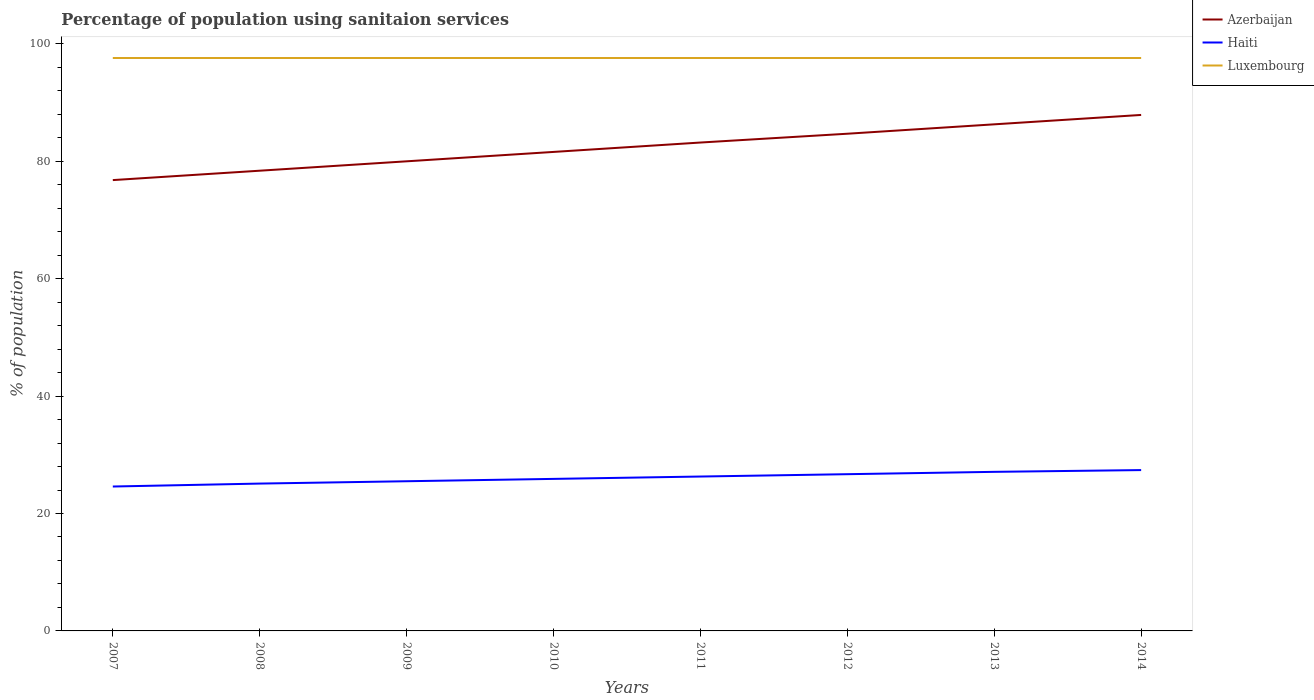Across all years, what is the maximum percentage of population using sanitaion services in Azerbaijan?
Offer a terse response. 76.8. What is the total percentage of population using sanitaion services in Azerbaijan in the graph?
Provide a succinct answer. -6.3. What is the difference between the highest and the second highest percentage of population using sanitaion services in Azerbaijan?
Make the answer very short. 11.1. How many lines are there?
Give a very brief answer. 3. How many years are there in the graph?
Keep it short and to the point. 8. What is the difference between two consecutive major ticks on the Y-axis?
Make the answer very short. 20. Are the values on the major ticks of Y-axis written in scientific E-notation?
Ensure brevity in your answer.  No. Does the graph contain any zero values?
Keep it short and to the point. No. What is the title of the graph?
Give a very brief answer. Percentage of population using sanitaion services. What is the label or title of the Y-axis?
Offer a terse response. % of population. What is the % of population in Azerbaijan in 2007?
Make the answer very short. 76.8. What is the % of population in Haiti in 2007?
Your answer should be compact. 24.6. What is the % of population in Luxembourg in 2007?
Give a very brief answer. 97.6. What is the % of population in Azerbaijan in 2008?
Give a very brief answer. 78.4. What is the % of population of Haiti in 2008?
Offer a very short reply. 25.1. What is the % of population of Luxembourg in 2008?
Provide a succinct answer. 97.6. What is the % of population in Azerbaijan in 2009?
Provide a succinct answer. 80. What is the % of population in Haiti in 2009?
Keep it short and to the point. 25.5. What is the % of population in Luxembourg in 2009?
Give a very brief answer. 97.6. What is the % of population of Azerbaijan in 2010?
Provide a succinct answer. 81.6. What is the % of population of Haiti in 2010?
Provide a succinct answer. 25.9. What is the % of population in Luxembourg in 2010?
Provide a succinct answer. 97.6. What is the % of population of Azerbaijan in 2011?
Your answer should be compact. 83.2. What is the % of population of Haiti in 2011?
Your response must be concise. 26.3. What is the % of population of Luxembourg in 2011?
Give a very brief answer. 97.6. What is the % of population of Azerbaijan in 2012?
Offer a very short reply. 84.7. What is the % of population in Haiti in 2012?
Offer a very short reply. 26.7. What is the % of population in Luxembourg in 2012?
Your answer should be compact. 97.6. What is the % of population in Azerbaijan in 2013?
Give a very brief answer. 86.3. What is the % of population in Haiti in 2013?
Make the answer very short. 27.1. What is the % of population of Luxembourg in 2013?
Provide a short and direct response. 97.6. What is the % of population of Azerbaijan in 2014?
Offer a terse response. 87.9. What is the % of population of Haiti in 2014?
Offer a terse response. 27.4. What is the % of population of Luxembourg in 2014?
Keep it short and to the point. 97.6. Across all years, what is the maximum % of population in Azerbaijan?
Offer a very short reply. 87.9. Across all years, what is the maximum % of population of Haiti?
Ensure brevity in your answer.  27.4. Across all years, what is the maximum % of population in Luxembourg?
Make the answer very short. 97.6. Across all years, what is the minimum % of population in Azerbaijan?
Offer a terse response. 76.8. Across all years, what is the minimum % of population of Haiti?
Offer a terse response. 24.6. Across all years, what is the minimum % of population of Luxembourg?
Keep it short and to the point. 97.6. What is the total % of population in Azerbaijan in the graph?
Offer a terse response. 658.9. What is the total % of population in Haiti in the graph?
Offer a terse response. 208.6. What is the total % of population of Luxembourg in the graph?
Offer a very short reply. 780.8. What is the difference between the % of population in Azerbaijan in 2007 and that in 2008?
Ensure brevity in your answer.  -1.6. What is the difference between the % of population in Luxembourg in 2007 and that in 2008?
Offer a terse response. 0. What is the difference between the % of population in Luxembourg in 2007 and that in 2009?
Ensure brevity in your answer.  0. What is the difference between the % of population of Azerbaijan in 2007 and that in 2010?
Keep it short and to the point. -4.8. What is the difference between the % of population of Luxembourg in 2007 and that in 2010?
Offer a terse response. 0. What is the difference between the % of population in Azerbaijan in 2007 and that in 2011?
Keep it short and to the point. -6.4. What is the difference between the % of population in Azerbaijan in 2007 and that in 2012?
Give a very brief answer. -7.9. What is the difference between the % of population of Azerbaijan in 2007 and that in 2013?
Offer a terse response. -9.5. What is the difference between the % of population in Azerbaijan in 2008 and that in 2009?
Provide a succinct answer. -1.6. What is the difference between the % of population of Haiti in 2008 and that in 2009?
Give a very brief answer. -0.4. What is the difference between the % of population of Luxembourg in 2008 and that in 2009?
Your response must be concise. 0. What is the difference between the % of population in Azerbaijan in 2008 and that in 2010?
Your response must be concise. -3.2. What is the difference between the % of population of Haiti in 2008 and that in 2010?
Your answer should be compact. -0.8. What is the difference between the % of population of Luxembourg in 2008 and that in 2010?
Offer a terse response. 0. What is the difference between the % of population of Azerbaijan in 2008 and that in 2014?
Provide a succinct answer. -9.5. What is the difference between the % of population in Luxembourg in 2008 and that in 2014?
Provide a short and direct response. 0. What is the difference between the % of population of Azerbaijan in 2009 and that in 2010?
Give a very brief answer. -1.6. What is the difference between the % of population in Haiti in 2009 and that in 2010?
Give a very brief answer. -0.4. What is the difference between the % of population in Haiti in 2009 and that in 2011?
Provide a succinct answer. -0.8. What is the difference between the % of population of Azerbaijan in 2009 and that in 2013?
Your response must be concise. -6.3. What is the difference between the % of population in Haiti in 2009 and that in 2013?
Make the answer very short. -1.6. What is the difference between the % of population in Luxembourg in 2009 and that in 2013?
Provide a short and direct response. 0. What is the difference between the % of population in Azerbaijan in 2009 and that in 2014?
Make the answer very short. -7.9. What is the difference between the % of population of Haiti in 2009 and that in 2014?
Provide a succinct answer. -1.9. What is the difference between the % of population in Luxembourg in 2009 and that in 2014?
Offer a terse response. 0. What is the difference between the % of population in Azerbaijan in 2010 and that in 2011?
Provide a succinct answer. -1.6. What is the difference between the % of population in Haiti in 2010 and that in 2011?
Offer a very short reply. -0.4. What is the difference between the % of population in Haiti in 2010 and that in 2013?
Your response must be concise. -1.2. What is the difference between the % of population in Luxembourg in 2010 and that in 2013?
Ensure brevity in your answer.  0. What is the difference between the % of population of Haiti in 2010 and that in 2014?
Make the answer very short. -1.5. What is the difference between the % of population of Azerbaijan in 2011 and that in 2012?
Give a very brief answer. -1.5. What is the difference between the % of population in Haiti in 2011 and that in 2012?
Ensure brevity in your answer.  -0.4. What is the difference between the % of population of Luxembourg in 2011 and that in 2012?
Ensure brevity in your answer.  0. What is the difference between the % of population in Azerbaijan in 2011 and that in 2013?
Provide a succinct answer. -3.1. What is the difference between the % of population in Luxembourg in 2011 and that in 2013?
Make the answer very short. 0. What is the difference between the % of population in Luxembourg in 2012 and that in 2014?
Your response must be concise. 0. What is the difference between the % of population of Azerbaijan in 2007 and the % of population of Haiti in 2008?
Offer a terse response. 51.7. What is the difference between the % of population in Azerbaijan in 2007 and the % of population in Luxembourg in 2008?
Your answer should be compact. -20.8. What is the difference between the % of population of Haiti in 2007 and the % of population of Luxembourg in 2008?
Offer a very short reply. -73. What is the difference between the % of population of Azerbaijan in 2007 and the % of population of Haiti in 2009?
Keep it short and to the point. 51.3. What is the difference between the % of population in Azerbaijan in 2007 and the % of population in Luxembourg in 2009?
Your answer should be compact. -20.8. What is the difference between the % of population of Haiti in 2007 and the % of population of Luxembourg in 2009?
Your answer should be very brief. -73. What is the difference between the % of population of Azerbaijan in 2007 and the % of population of Haiti in 2010?
Make the answer very short. 50.9. What is the difference between the % of population of Azerbaijan in 2007 and the % of population of Luxembourg in 2010?
Offer a terse response. -20.8. What is the difference between the % of population in Haiti in 2007 and the % of population in Luxembourg in 2010?
Your response must be concise. -73. What is the difference between the % of population in Azerbaijan in 2007 and the % of population in Haiti in 2011?
Keep it short and to the point. 50.5. What is the difference between the % of population of Azerbaijan in 2007 and the % of population of Luxembourg in 2011?
Make the answer very short. -20.8. What is the difference between the % of population of Haiti in 2007 and the % of population of Luxembourg in 2011?
Your answer should be very brief. -73. What is the difference between the % of population of Azerbaijan in 2007 and the % of population of Haiti in 2012?
Make the answer very short. 50.1. What is the difference between the % of population in Azerbaijan in 2007 and the % of population in Luxembourg in 2012?
Give a very brief answer. -20.8. What is the difference between the % of population of Haiti in 2007 and the % of population of Luxembourg in 2012?
Provide a succinct answer. -73. What is the difference between the % of population in Azerbaijan in 2007 and the % of population in Haiti in 2013?
Give a very brief answer. 49.7. What is the difference between the % of population of Azerbaijan in 2007 and the % of population of Luxembourg in 2013?
Provide a short and direct response. -20.8. What is the difference between the % of population in Haiti in 2007 and the % of population in Luxembourg in 2013?
Your answer should be very brief. -73. What is the difference between the % of population in Azerbaijan in 2007 and the % of population in Haiti in 2014?
Offer a very short reply. 49.4. What is the difference between the % of population of Azerbaijan in 2007 and the % of population of Luxembourg in 2014?
Offer a very short reply. -20.8. What is the difference between the % of population of Haiti in 2007 and the % of population of Luxembourg in 2014?
Your response must be concise. -73. What is the difference between the % of population in Azerbaijan in 2008 and the % of population in Haiti in 2009?
Your answer should be compact. 52.9. What is the difference between the % of population in Azerbaijan in 2008 and the % of population in Luxembourg in 2009?
Your answer should be compact. -19.2. What is the difference between the % of population in Haiti in 2008 and the % of population in Luxembourg in 2009?
Make the answer very short. -72.5. What is the difference between the % of population of Azerbaijan in 2008 and the % of population of Haiti in 2010?
Provide a short and direct response. 52.5. What is the difference between the % of population in Azerbaijan in 2008 and the % of population in Luxembourg in 2010?
Keep it short and to the point. -19.2. What is the difference between the % of population of Haiti in 2008 and the % of population of Luxembourg in 2010?
Your answer should be very brief. -72.5. What is the difference between the % of population in Azerbaijan in 2008 and the % of population in Haiti in 2011?
Provide a short and direct response. 52.1. What is the difference between the % of population in Azerbaijan in 2008 and the % of population in Luxembourg in 2011?
Offer a very short reply. -19.2. What is the difference between the % of population of Haiti in 2008 and the % of population of Luxembourg in 2011?
Make the answer very short. -72.5. What is the difference between the % of population of Azerbaijan in 2008 and the % of population of Haiti in 2012?
Give a very brief answer. 51.7. What is the difference between the % of population of Azerbaijan in 2008 and the % of population of Luxembourg in 2012?
Offer a very short reply. -19.2. What is the difference between the % of population of Haiti in 2008 and the % of population of Luxembourg in 2012?
Your response must be concise. -72.5. What is the difference between the % of population in Azerbaijan in 2008 and the % of population in Haiti in 2013?
Provide a succinct answer. 51.3. What is the difference between the % of population of Azerbaijan in 2008 and the % of population of Luxembourg in 2013?
Provide a short and direct response. -19.2. What is the difference between the % of population in Haiti in 2008 and the % of population in Luxembourg in 2013?
Offer a very short reply. -72.5. What is the difference between the % of population in Azerbaijan in 2008 and the % of population in Haiti in 2014?
Ensure brevity in your answer.  51. What is the difference between the % of population of Azerbaijan in 2008 and the % of population of Luxembourg in 2014?
Keep it short and to the point. -19.2. What is the difference between the % of population in Haiti in 2008 and the % of population in Luxembourg in 2014?
Provide a succinct answer. -72.5. What is the difference between the % of population in Azerbaijan in 2009 and the % of population in Haiti in 2010?
Make the answer very short. 54.1. What is the difference between the % of population of Azerbaijan in 2009 and the % of population of Luxembourg in 2010?
Your answer should be very brief. -17.6. What is the difference between the % of population in Haiti in 2009 and the % of population in Luxembourg in 2010?
Provide a short and direct response. -72.1. What is the difference between the % of population in Azerbaijan in 2009 and the % of population in Haiti in 2011?
Offer a very short reply. 53.7. What is the difference between the % of population of Azerbaijan in 2009 and the % of population of Luxembourg in 2011?
Your answer should be very brief. -17.6. What is the difference between the % of population in Haiti in 2009 and the % of population in Luxembourg in 2011?
Give a very brief answer. -72.1. What is the difference between the % of population of Azerbaijan in 2009 and the % of population of Haiti in 2012?
Offer a terse response. 53.3. What is the difference between the % of population in Azerbaijan in 2009 and the % of population in Luxembourg in 2012?
Your response must be concise. -17.6. What is the difference between the % of population of Haiti in 2009 and the % of population of Luxembourg in 2012?
Give a very brief answer. -72.1. What is the difference between the % of population of Azerbaijan in 2009 and the % of population of Haiti in 2013?
Give a very brief answer. 52.9. What is the difference between the % of population in Azerbaijan in 2009 and the % of population in Luxembourg in 2013?
Your answer should be compact. -17.6. What is the difference between the % of population in Haiti in 2009 and the % of population in Luxembourg in 2013?
Provide a succinct answer. -72.1. What is the difference between the % of population in Azerbaijan in 2009 and the % of population in Haiti in 2014?
Ensure brevity in your answer.  52.6. What is the difference between the % of population of Azerbaijan in 2009 and the % of population of Luxembourg in 2014?
Offer a very short reply. -17.6. What is the difference between the % of population of Haiti in 2009 and the % of population of Luxembourg in 2014?
Offer a terse response. -72.1. What is the difference between the % of population of Azerbaijan in 2010 and the % of population of Haiti in 2011?
Provide a short and direct response. 55.3. What is the difference between the % of population in Haiti in 2010 and the % of population in Luxembourg in 2011?
Ensure brevity in your answer.  -71.7. What is the difference between the % of population of Azerbaijan in 2010 and the % of population of Haiti in 2012?
Give a very brief answer. 54.9. What is the difference between the % of population in Haiti in 2010 and the % of population in Luxembourg in 2012?
Provide a short and direct response. -71.7. What is the difference between the % of population of Azerbaijan in 2010 and the % of population of Haiti in 2013?
Your answer should be compact. 54.5. What is the difference between the % of population in Haiti in 2010 and the % of population in Luxembourg in 2013?
Provide a succinct answer. -71.7. What is the difference between the % of population of Azerbaijan in 2010 and the % of population of Haiti in 2014?
Keep it short and to the point. 54.2. What is the difference between the % of population in Azerbaijan in 2010 and the % of population in Luxembourg in 2014?
Ensure brevity in your answer.  -16. What is the difference between the % of population of Haiti in 2010 and the % of population of Luxembourg in 2014?
Give a very brief answer. -71.7. What is the difference between the % of population of Azerbaijan in 2011 and the % of population of Haiti in 2012?
Provide a short and direct response. 56.5. What is the difference between the % of population of Azerbaijan in 2011 and the % of population of Luxembourg in 2012?
Your response must be concise. -14.4. What is the difference between the % of population in Haiti in 2011 and the % of population in Luxembourg in 2012?
Your answer should be compact. -71.3. What is the difference between the % of population in Azerbaijan in 2011 and the % of population in Haiti in 2013?
Offer a terse response. 56.1. What is the difference between the % of population in Azerbaijan in 2011 and the % of population in Luxembourg in 2013?
Offer a very short reply. -14.4. What is the difference between the % of population in Haiti in 2011 and the % of population in Luxembourg in 2013?
Your answer should be compact. -71.3. What is the difference between the % of population of Azerbaijan in 2011 and the % of population of Haiti in 2014?
Keep it short and to the point. 55.8. What is the difference between the % of population of Azerbaijan in 2011 and the % of population of Luxembourg in 2014?
Keep it short and to the point. -14.4. What is the difference between the % of population in Haiti in 2011 and the % of population in Luxembourg in 2014?
Give a very brief answer. -71.3. What is the difference between the % of population of Azerbaijan in 2012 and the % of population of Haiti in 2013?
Your answer should be very brief. 57.6. What is the difference between the % of population in Haiti in 2012 and the % of population in Luxembourg in 2013?
Ensure brevity in your answer.  -70.9. What is the difference between the % of population in Azerbaijan in 2012 and the % of population in Haiti in 2014?
Provide a short and direct response. 57.3. What is the difference between the % of population of Haiti in 2012 and the % of population of Luxembourg in 2014?
Offer a terse response. -70.9. What is the difference between the % of population of Azerbaijan in 2013 and the % of population of Haiti in 2014?
Give a very brief answer. 58.9. What is the difference between the % of population of Azerbaijan in 2013 and the % of population of Luxembourg in 2014?
Your answer should be very brief. -11.3. What is the difference between the % of population in Haiti in 2013 and the % of population in Luxembourg in 2014?
Your answer should be compact. -70.5. What is the average % of population of Azerbaijan per year?
Your answer should be compact. 82.36. What is the average % of population of Haiti per year?
Give a very brief answer. 26.07. What is the average % of population of Luxembourg per year?
Ensure brevity in your answer.  97.6. In the year 2007, what is the difference between the % of population of Azerbaijan and % of population of Haiti?
Provide a succinct answer. 52.2. In the year 2007, what is the difference between the % of population of Azerbaijan and % of population of Luxembourg?
Your response must be concise. -20.8. In the year 2007, what is the difference between the % of population in Haiti and % of population in Luxembourg?
Your response must be concise. -73. In the year 2008, what is the difference between the % of population of Azerbaijan and % of population of Haiti?
Your response must be concise. 53.3. In the year 2008, what is the difference between the % of population in Azerbaijan and % of population in Luxembourg?
Ensure brevity in your answer.  -19.2. In the year 2008, what is the difference between the % of population in Haiti and % of population in Luxembourg?
Provide a short and direct response. -72.5. In the year 2009, what is the difference between the % of population of Azerbaijan and % of population of Haiti?
Provide a succinct answer. 54.5. In the year 2009, what is the difference between the % of population of Azerbaijan and % of population of Luxembourg?
Your answer should be compact. -17.6. In the year 2009, what is the difference between the % of population in Haiti and % of population in Luxembourg?
Provide a succinct answer. -72.1. In the year 2010, what is the difference between the % of population of Azerbaijan and % of population of Haiti?
Offer a very short reply. 55.7. In the year 2010, what is the difference between the % of population in Azerbaijan and % of population in Luxembourg?
Keep it short and to the point. -16. In the year 2010, what is the difference between the % of population of Haiti and % of population of Luxembourg?
Offer a terse response. -71.7. In the year 2011, what is the difference between the % of population in Azerbaijan and % of population in Haiti?
Provide a short and direct response. 56.9. In the year 2011, what is the difference between the % of population of Azerbaijan and % of population of Luxembourg?
Keep it short and to the point. -14.4. In the year 2011, what is the difference between the % of population of Haiti and % of population of Luxembourg?
Your answer should be compact. -71.3. In the year 2012, what is the difference between the % of population of Azerbaijan and % of population of Luxembourg?
Ensure brevity in your answer.  -12.9. In the year 2012, what is the difference between the % of population of Haiti and % of population of Luxembourg?
Provide a succinct answer. -70.9. In the year 2013, what is the difference between the % of population in Azerbaijan and % of population in Haiti?
Provide a short and direct response. 59.2. In the year 2013, what is the difference between the % of population of Haiti and % of population of Luxembourg?
Keep it short and to the point. -70.5. In the year 2014, what is the difference between the % of population in Azerbaijan and % of population in Haiti?
Keep it short and to the point. 60.5. In the year 2014, what is the difference between the % of population of Azerbaijan and % of population of Luxembourg?
Your answer should be compact. -9.7. In the year 2014, what is the difference between the % of population in Haiti and % of population in Luxembourg?
Provide a short and direct response. -70.2. What is the ratio of the % of population in Azerbaijan in 2007 to that in 2008?
Give a very brief answer. 0.98. What is the ratio of the % of population in Haiti in 2007 to that in 2008?
Offer a terse response. 0.98. What is the ratio of the % of population in Haiti in 2007 to that in 2009?
Your answer should be compact. 0.96. What is the ratio of the % of population of Luxembourg in 2007 to that in 2009?
Provide a short and direct response. 1. What is the ratio of the % of population in Haiti in 2007 to that in 2010?
Your response must be concise. 0.95. What is the ratio of the % of population in Luxembourg in 2007 to that in 2010?
Your response must be concise. 1. What is the ratio of the % of population in Azerbaijan in 2007 to that in 2011?
Keep it short and to the point. 0.92. What is the ratio of the % of population of Haiti in 2007 to that in 2011?
Your response must be concise. 0.94. What is the ratio of the % of population of Azerbaijan in 2007 to that in 2012?
Offer a very short reply. 0.91. What is the ratio of the % of population in Haiti in 2007 to that in 2012?
Give a very brief answer. 0.92. What is the ratio of the % of population in Luxembourg in 2007 to that in 2012?
Your response must be concise. 1. What is the ratio of the % of population in Azerbaijan in 2007 to that in 2013?
Ensure brevity in your answer.  0.89. What is the ratio of the % of population of Haiti in 2007 to that in 2013?
Offer a very short reply. 0.91. What is the ratio of the % of population of Azerbaijan in 2007 to that in 2014?
Your answer should be compact. 0.87. What is the ratio of the % of population of Haiti in 2007 to that in 2014?
Give a very brief answer. 0.9. What is the ratio of the % of population in Luxembourg in 2007 to that in 2014?
Your response must be concise. 1. What is the ratio of the % of population in Azerbaijan in 2008 to that in 2009?
Your response must be concise. 0.98. What is the ratio of the % of population in Haiti in 2008 to that in 2009?
Your answer should be compact. 0.98. What is the ratio of the % of population in Luxembourg in 2008 to that in 2009?
Keep it short and to the point. 1. What is the ratio of the % of population of Azerbaijan in 2008 to that in 2010?
Offer a very short reply. 0.96. What is the ratio of the % of population in Haiti in 2008 to that in 2010?
Ensure brevity in your answer.  0.97. What is the ratio of the % of population of Luxembourg in 2008 to that in 2010?
Give a very brief answer. 1. What is the ratio of the % of population in Azerbaijan in 2008 to that in 2011?
Offer a very short reply. 0.94. What is the ratio of the % of population in Haiti in 2008 to that in 2011?
Your response must be concise. 0.95. What is the ratio of the % of population in Luxembourg in 2008 to that in 2011?
Your answer should be very brief. 1. What is the ratio of the % of population of Azerbaijan in 2008 to that in 2012?
Give a very brief answer. 0.93. What is the ratio of the % of population of Haiti in 2008 to that in 2012?
Your answer should be compact. 0.94. What is the ratio of the % of population in Azerbaijan in 2008 to that in 2013?
Give a very brief answer. 0.91. What is the ratio of the % of population of Haiti in 2008 to that in 2013?
Give a very brief answer. 0.93. What is the ratio of the % of population in Luxembourg in 2008 to that in 2013?
Your response must be concise. 1. What is the ratio of the % of population of Azerbaijan in 2008 to that in 2014?
Offer a very short reply. 0.89. What is the ratio of the % of population in Haiti in 2008 to that in 2014?
Give a very brief answer. 0.92. What is the ratio of the % of population in Luxembourg in 2008 to that in 2014?
Ensure brevity in your answer.  1. What is the ratio of the % of population in Azerbaijan in 2009 to that in 2010?
Your response must be concise. 0.98. What is the ratio of the % of population of Haiti in 2009 to that in 2010?
Make the answer very short. 0.98. What is the ratio of the % of population in Luxembourg in 2009 to that in 2010?
Give a very brief answer. 1. What is the ratio of the % of population in Azerbaijan in 2009 to that in 2011?
Offer a terse response. 0.96. What is the ratio of the % of population of Haiti in 2009 to that in 2011?
Offer a terse response. 0.97. What is the ratio of the % of population in Luxembourg in 2009 to that in 2011?
Provide a short and direct response. 1. What is the ratio of the % of population of Azerbaijan in 2009 to that in 2012?
Your answer should be compact. 0.94. What is the ratio of the % of population of Haiti in 2009 to that in 2012?
Your answer should be very brief. 0.96. What is the ratio of the % of population in Luxembourg in 2009 to that in 2012?
Make the answer very short. 1. What is the ratio of the % of population of Azerbaijan in 2009 to that in 2013?
Ensure brevity in your answer.  0.93. What is the ratio of the % of population in Haiti in 2009 to that in 2013?
Provide a short and direct response. 0.94. What is the ratio of the % of population in Luxembourg in 2009 to that in 2013?
Offer a very short reply. 1. What is the ratio of the % of population of Azerbaijan in 2009 to that in 2014?
Provide a short and direct response. 0.91. What is the ratio of the % of population of Haiti in 2009 to that in 2014?
Keep it short and to the point. 0.93. What is the ratio of the % of population in Azerbaijan in 2010 to that in 2011?
Offer a very short reply. 0.98. What is the ratio of the % of population of Haiti in 2010 to that in 2011?
Provide a short and direct response. 0.98. What is the ratio of the % of population in Luxembourg in 2010 to that in 2011?
Provide a succinct answer. 1. What is the ratio of the % of population in Azerbaijan in 2010 to that in 2012?
Make the answer very short. 0.96. What is the ratio of the % of population in Azerbaijan in 2010 to that in 2013?
Offer a very short reply. 0.95. What is the ratio of the % of population of Haiti in 2010 to that in 2013?
Your answer should be very brief. 0.96. What is the ratio of the % of population in Luxembourg in 2010 to that in 2013?
Offer a terse response. 1. What is the ratio of the % of population in Azerbaijan in 2010 to that in 2014?
Provide a short and direct response. 0.93. What is the ratio of the % of population in Haiti in 2010 to that in 2014?
Your response must be concise. 0.95. What is the ratio of the % of population in Azerbaijan in 2011 to that in 2012?
Your answer should be very brief. 0.98. What is the ratio of the % of population of Haiti in 2011 to that in 2012?
Your answer should be very brief. 0.98. What is the ratio of the % of population of Luxembourg in 2011 to that in 2012?
Keep it short and to the point. 1. What is the ratio of the % of population in Azerbaijan in 2011 to that in 2013?
Offer a very short reply. 0.96. What is the ratio of the % of population of Haiti in 2011 to that in 2013?
Ensure brevity in your answer.  0.97. What is the ratio of the % of population of Azerbaijan in 2011 to that in 2014?
Offer a very short reply. 0.95. What is the ratio of the % of population of Haiti in 2011 to that in 2014?
Ensure brevity in your answer.  0.96. What is the ratio of the % of population of Azerbaijan in 2012 to that in 2013?
Your response must be concise. 0.98. What is the ratio of the % of population in Haiti in 2012 to that in 2013?
Offer a very short reply. 0.99. What is the ratio of the % of population of Azerbaijan in 2012 to that in 2014?
Offer a very short reply. 0.96. What is the ratio of the % of population of Haiti in 2012 to that in 2014?
Ensure brevity in your answer.  0.97. What is the ratio of the % of population in Azerbaijan in 2013 to that in 2014?
Your answer should be very brief. 0.98. What is the difference between the highest and the second highest % of population of Luxembourg?
Ensure brevity in your answer.  0. What is the difference between the highest and the lowest % of population of Haiti?
Give a very brief answer. 2.8. What is the difference between the highest and the lowest % of population in Luxembourg?
Offer a very short reply. 0. 